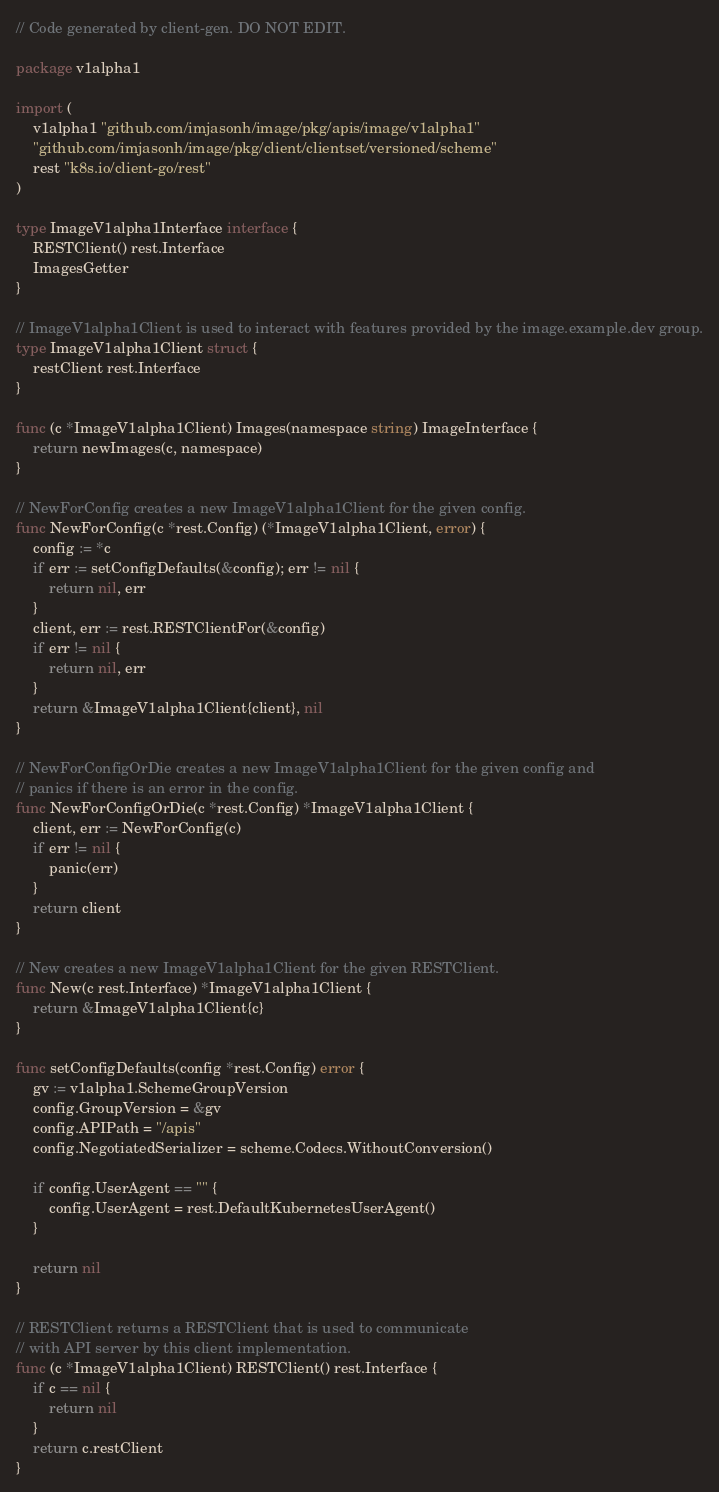Convert code to text. <code><loc_0><loc_0><loc_500><loc_500><_Go_>// Code generated by client-gen. DO NOT EDIT.

package v1alpha1

import (
	v1alpha1 "github.com/imjasonh/image/pkg/apis/image/v1alpha1"
	"github.com/imjasonh/image/pkg/client/clientset/versioned/scheme"
	rest "k8s.io/client-go/rest"
)

type ImageV1alpha1Interface interface {
	RESTClient() rest.Interface
	ImagesGetter
}

// ImageV1alpha1Client is used to interact with features provided by the image.example.dev group.
type ImageV1alpha1Client struct {
	restClient rest.Interface
}

func (c *ImageV1alpha1Client) Images(namespace string) ImageInterface {
	return newImages(c, namespace)
}

// NewForConfig creates a new ImageV1alpha1Client for the given config.
func NewForConfig(c *rest.Config) (*ImageV1alpha1Client, error) {
	config := *c
	if err := setConfigDefaults(&config); err != nil {
		return nil, err
	}
	client, err := rest.RESTClientFor(&config)
	if err != nil {
		return nil, err
	}
	return &ImageV1alpha1Client{client}, nil
}

// NewForConfigOrDie creates a new ImageV1alpha1Client for the given config and
// panics if there is an error in the config.
func NewForConfigOrDie(c *rest.Config) *ImageV1alpha1Client {
	client, err := NewForConfig(c)
	if err != nil {
		panic(err)
	}
	return client
}

// New creates a new ImageV1alpha1Client for the given RESTClient.
func New(c rest.Interface) *ImageV1alpha1Client {
	return &ImageV1alpha1Client{c}
}

func setConfigDefaults(config *rest.Config) error {
	gv := v1alpha1.SchemeGroupVersion
	config.GroupVersion = &gv
	config.APIPath = "/apis"
	config.NegotiatedSerializer = scheme.Codecs.WithoutConversion()

	if config.UserAgent == "" {
		config.UserAgent = rest.DefaultKubernetesUserAgent()
	}

	return nil
}

// RESTClient returns a RESTClient that is used to communicate
// with API server by this client implementation.
func (c *ImageV1alpha1Client) RESTClient() rest.Interface {
	if c == nil {
		return nil
	}
	return c.restClient
}
</code> 